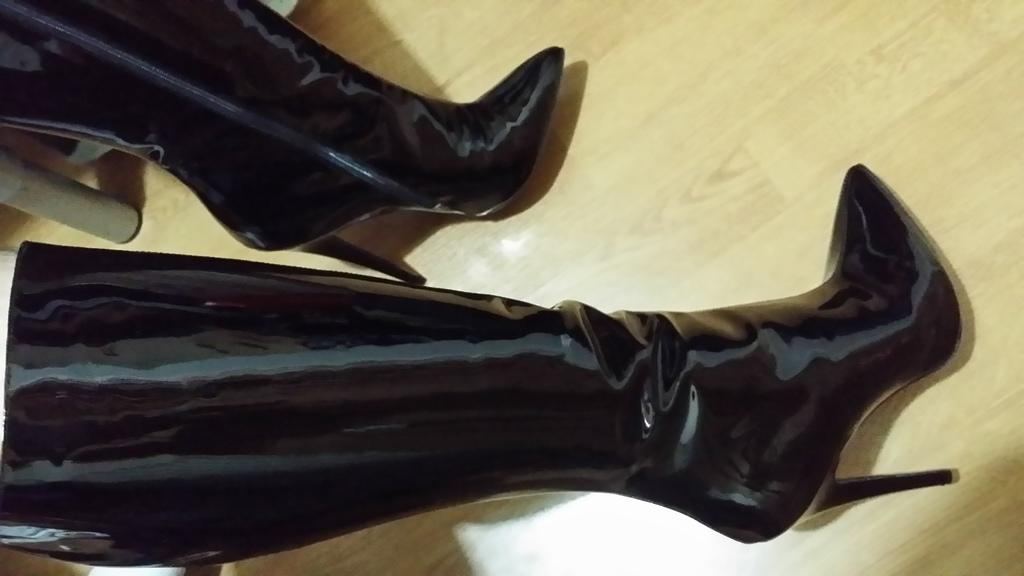What type of footwear is visible in the image? There are mid-calf boots in the image. What type of flooring is present at the bottom of the image? There is wooden flooring at the bottom of the image. What type of bird can be seen perched on the boots in the image? There is no bird present in the image, and therefore no such activity can be observed. What type of metal is used to make the boots in the image? The facts provided do not mention the material used to make the boots, so it cannot be determined from the image. 